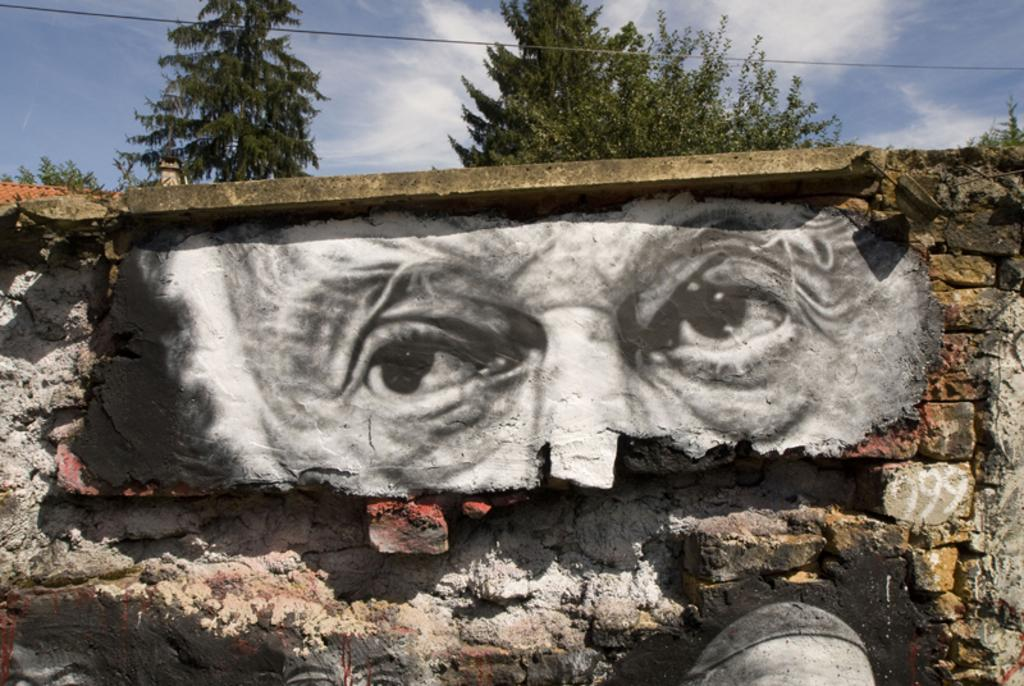What is the main subject in the center of the image? There is a wall in the center of the image. What is depicted on the wall? The wall has a painting of a person's eyes. What can be seen in the background of the image? There are trees and sky visible in the background of the image. What else is present in the background of the image? There is a wire in the background of the image. What rule is being enforced by the person's eyes in the image? There is no rule being enforced by the person's eyes in the image; it is a painting on a wall. How is the earth represented in the image? The image does not depict the earth; it features a wall with a painting of a person's eyes, trees, sky, and a wire in the background. 